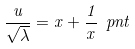Convert formula to latex. <formula><loc_0><loc_0><loc_500><loc_500>\frac { u } { \sqrt { \lambda } } = x + \frac { 1 } { x } \ p n t</formula> 